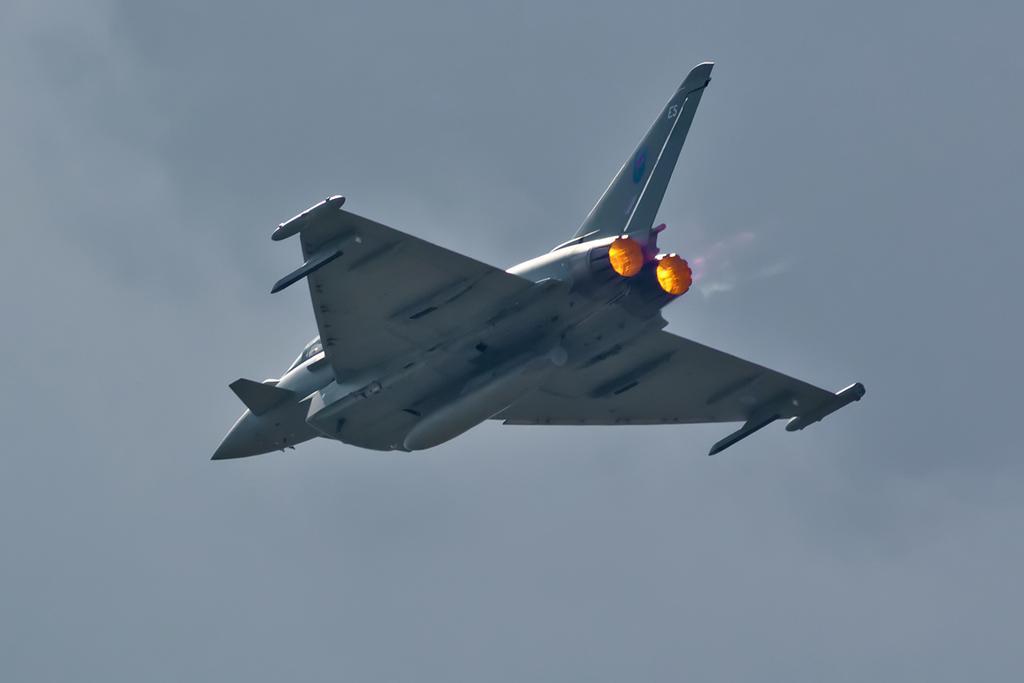How would you summarize this image in a sentence or two? As we can see in the image there is sky and jet plane. 